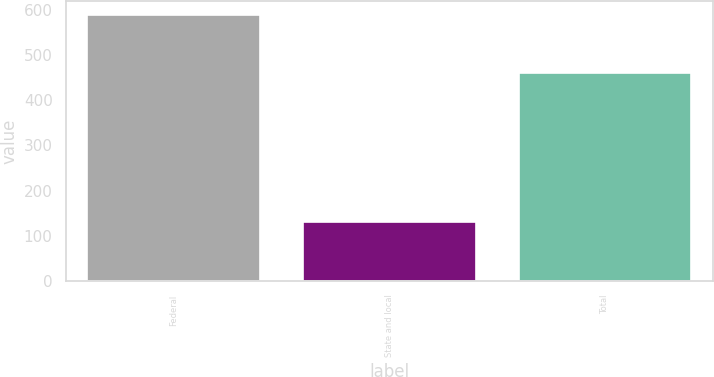Convert chart. <chart><loc_0><loc_0><loc_500><loc_500><bar_chart><fcel>Federal<fcel>State and local<fcel>Total<nl><fcel>589<fcel>131<fcel>460<nl></chart> 